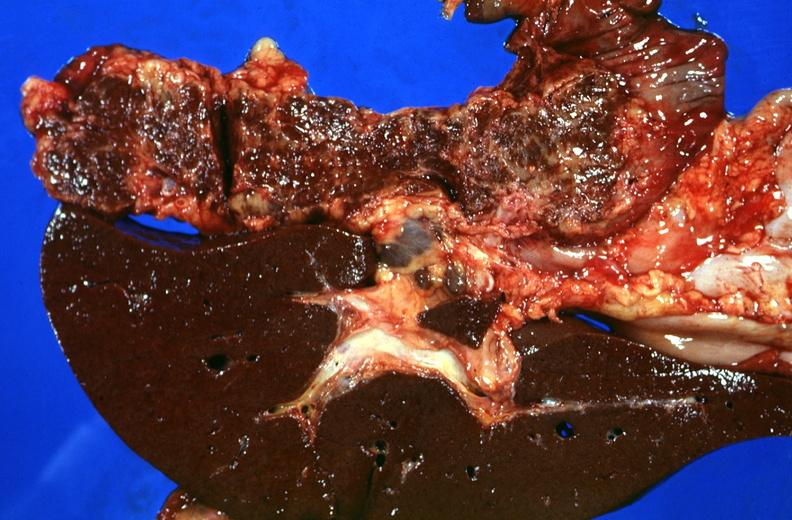s notochord present?
Answer the question using a single word or phrase. No 